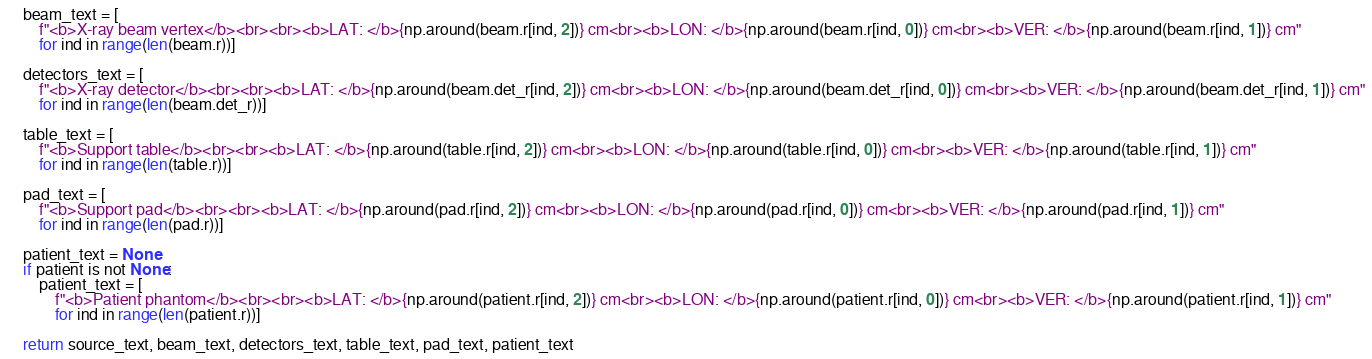Convert code to text. <code><loc_0><loc_0><loc_500><loc_500><_Python_>
    beam_text = [
        f"<b>X-ray beam vertex</b><br><br><b>LAT: </b>{np.around(beam.r[ind, 2])} cm<br><b>LON: </b>{np.around(beam.r[ind, 0])} cm<br><b>VER: </b>{np.around(beam.r[ind, 1])} cm"
        for ind in range(len(beam.r))]

    detectors_text = [
        f"<b>X-ray detector</b><br><br><b>LAT: </b>{np.around(beam.det_r[ind, 2])} cm<br><b>LON: </b>{np.around(beam.det_r[ind, 0])} cm<br><b>VER: </b>{np.around(beam.det_r[ind, 1])} cm"
        for ind in range(len(beam.det_r))]

    table_text = [
        f"<b>Support table</b><br><br><b>LAT: </b>{np.around(table.r[ind, 2])} cm<br><b>LON: </b>{np.around(table.r[ind, 0])} cm<br><b>VER: </b>{np.around(table.r[ind, 1])} cm"
        for ind in range(len(table.r))]

    pad_text = [
        f"<b>Support pad</b><br><br><b>LAT: </b>{np.around(pad.r[ind, 2])} cm<br><b>LON: </b>{np.around(pad.r[ind, 0])} cm<br><b>VER: </b>{np.around(pad.r[ind, 1])} cm"
        for ind in range(len(pad.r))]

    patient_text = None
    if patient is not None:
        patient_text = [
            f"<b>Patient phantom</b><br><br><b>LAT: </b>{np.around(patient.r[ind, 2])} cm<br><b>LON: </b>{np.around(patient.r[ind, 0])} cm<br><b>VER: </b>{np.around(patient.r[ind, 1])} cm"
            for ind in range(len(patient.r))]

    return source_text, beam_text, detectors_text, table_text, pad_text, patient_text
</code> 